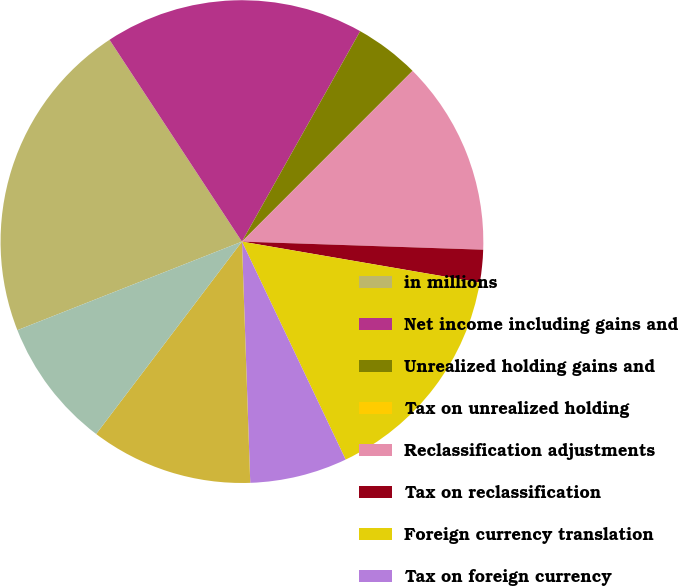Convert chart to OTSL. <chart><loc_0><loc_0><loc_500><loc_500><pie_chart><fcel>in millions<fcel>Net income including gains and<fcel>Unrealized holding gains and<fcel>Tax on unrealized holding<fcel>Reclassification adjustments<fcel>Tax on reclassification<fcel>Foreign currency translation<fcel>Tax on foreign currency<fcel>Adjustments to employee<fcel>Tax on adjustments to employee<nl><fcel>21.74%<fcel>17.39%<fcel>4.35%<fcel>0.0%<fcel>13.04%<fcel>2.18%<fcel>15.22%<fcel>6.52%<fcel>10.87%<fcel>8.7%<nl></chart> 